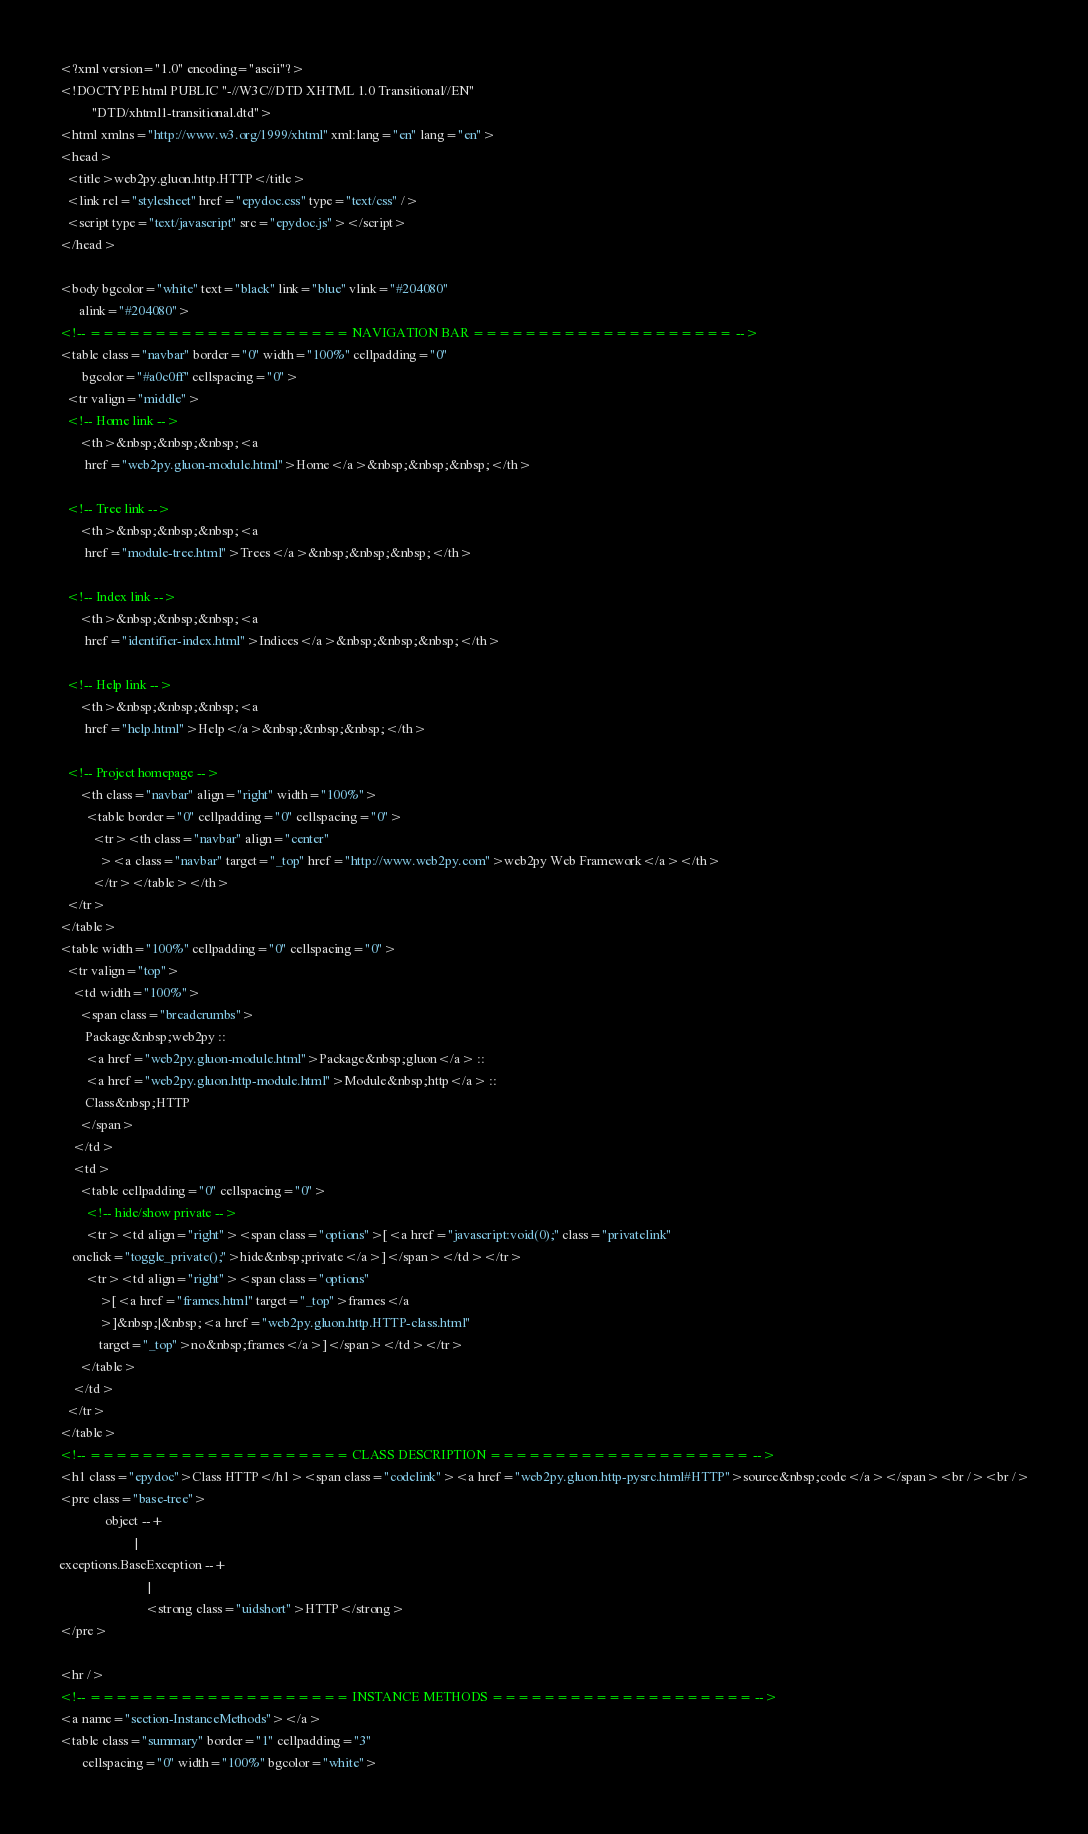Convert code to text. <code><loc_0><loc_0><loc_500><loc_500><_HTML_><?xml version="1.0" encoding="ascii"?>
<!DOCTYPE html PUBLIC "-//W3C//DTD XHTML 1.0 Transitional//EN"
          "DTD/xhtml1-transitional.dtd">
<html xmlns="http://www.w3.org/1999/xhtml" xml:lang="en" lang="en">
<head>
  <title>web2py.gluon.http.HTTP</title>
  <link rel="stylesheet" href="epydoc.css" type="text/css" />
  <script type="text/javascript" src="epydoc.js"></script>
</head>

<body bgcolor="white" text="black" link="blue" vlink="#204080"
      alink="#204080">
<!-- ==================== NAVIGATION BAR ==================== -->
<table class="navbar" border="0" width="100%" cellpadding="0"
       bgcolor="#a0c0ff" cellspacing="0">
  <tr valign="middle">
  <!-- Home link -->
      <th>&nbsp;&nbsp;&nbsp;<a
        href="web2py.gluon-module.html">Home</a>&nbsp;&nbsp;&nbsp;</th>

  <!-- Tree link -->
      <th>&nbsp;&nbsp;&nbsp;<a
        href="module-tree.html">Trees</a>&nbsp;&nbsp;&nbsp;</th>

  <!-- Index link -->
      <th>&nbsp;&nbsp;&nbsp;<a
        href="identifier-index.html">Indices</a>&nbsp;&nbsp;&nbsp;</th>

  <!-- Help link -->
      <th>&nbsp;&nbsp;&nbsp;<a
        href="help.html">Help</a>&nbsp;&nbsp;&nbsp;</th>

  <!-- Project homepage -->
      <th class="navbar" align="right" width="100%">
        <table border="0" cellpadding="0" cellspacing="0">
          <tr><th class="navbar" align="center"
            ><a class="navbar" target="_top" href="http://www.web2py.com">web2py Web Framework</a></th>
          </tr></table></th>
  </tr>
</table>
<table width="100%" cellpadding="0" cellspacing="0">
  <tr valign="top">
    <td width="100%">
      <span class="breadcrumbs">
        Package&nbsp;web2py ::
        <a href="web2py.gluon-module.html">Package&nbsp;gluon</a> ::
        <a href="web2py.gluon.http-module.html">Module&nbsp;http</a> ::
        Class&nbsp;HTTP
      </span>
    </td>
    <td>
      <table cellpadding="0" cellspacing="0">
        <!-- hide/show private -->
        <tr><td align="right"><span class="options">[<a href="javascript:void(0);" class="privatelink"
    onclick="toggle_private();">hide&nbsp;private</a>]</span></td></tr>
        <tr><td align="right"><span class="options"
            >[<a href="frames.html" target="_top">frames</a
            >]&nbsp;|&nbsp;<a href="web2py.gluon.http.HTTP-class.html"
            target="_top">no&nbsp;frames</a>]</span></td></tr>
      </table>
    </td>
  </tr>
</table>
<!-- ==================== CLASS DESCRIPTION ==================== -->
<h1 class="epydoc">Class HTTP</h1><span class="codelink"><a href="web2py.gluon.http-pysrc.html#HTTP">source&nbsp;code</a></span><br /><br />
<pre class="base-tree">
              object --+    
                       |    
exceptions.BaseException --+
                           |
                          <strong class="uidshort">HTTP</strong>
</pre>

<hr />
<!-- ==================== INSTANCE METHODS ==================== -->
<a name="section-InstanceMethods"></a>
<table class="summary" border="1" cellpadding="3"
       cellspacing="0" width="100%" bgcolor="white"></code> 